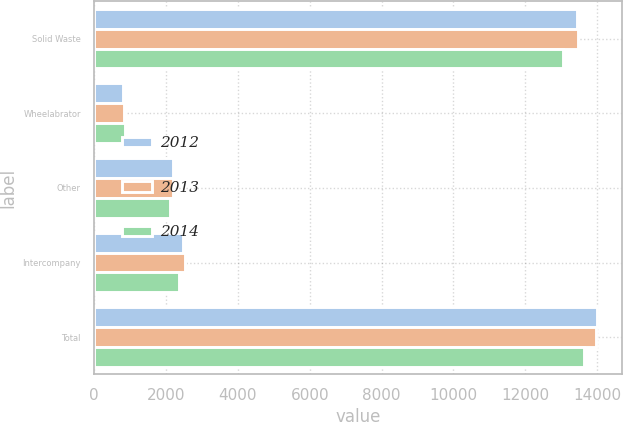Convert chart. <chart><loc_0><loc_0><loc_500><loc_500><stacked_bar_chart><ecel><fcel>Solid Waste<fcel>Wheelabrator<fcel>Other<fcel>Intercompany<fcel>Total<nl><fcel>2012<fcel>13449<fcel>817<fcel>2191<fcel>2461<fcel>13996<nl><fcel>2013<fcel>13477<fcel>845<fcel>2185<fcel>2524<fcel>13983<nl><fcel>2014<fcel>13056<fcel>846<fcel>2106<fcel>2359<fcel>13649<nl></chart> 